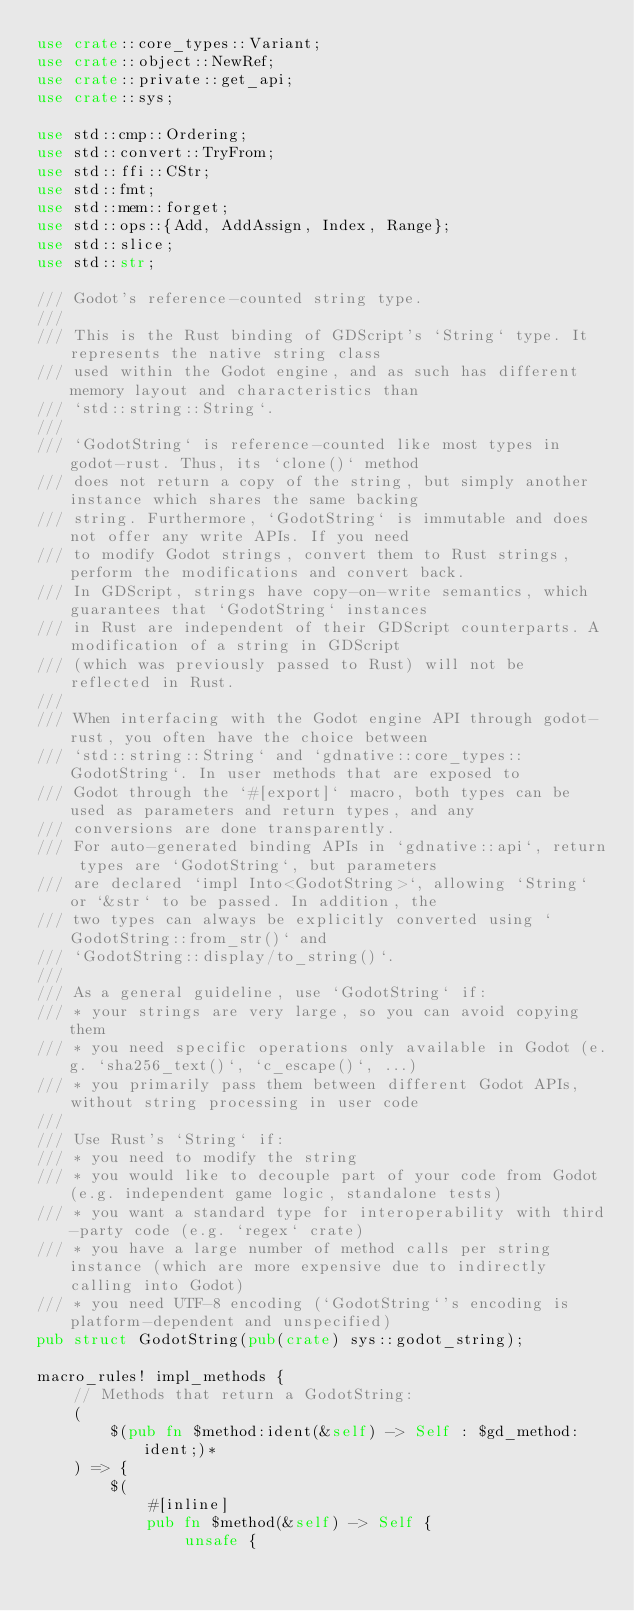<code> <loc_0><loc_0><loc_500><loc_500><_Rust_>use crate::core_types::Variant;
use crate::object::NewRef;
use crate::private::get_api;
use crate::sys;

use std::cmp::Ordering;
use std::convert::TryFrom;
use std::ffi::CStr;
use std::fmt;
use std::mem::forget;
use std::ops::{Add, AddAssign, Index, Range};
use std::slice;
use std::str;

/// Godot's reference-counted string type.
///
/// This is the Rust binding of GDScript's `String` type. It represents the native string class
/// used within the Godot engine, and as such has different memory layout and characteristics than
/// `std::string::String`.
///
/// `GodotString` is reference-counted like most types in godot-rust. Thus, its `clone()` method
/// does not return a copy of the string, but simply another instance which shares the same backing
/// string. Furthermore, `GodotString` is immutable and does not offer any write APIs. If you need
/// to modify Godot strings, convert them to Rust strings, perform the modifications and convert back.
/// In GDScript, strings have copy-on-write semantics, which guarantees that `GodotString` instances
/// in Rust are independent of their GDScript counterparts. A modification of a string in GDScript
/// (which was previously passed to Rust) will not be reflected in Rust.
///
/// When interfacing with the Godot engine API through godot-rust, you often have the choice between
/// `std::string::String` and `gdnative::core_types::GodotString`. In user methods that are exposed to
/// Godot through the `#[export]` macro, both types can be used as parameters and return types, and any
/// conversions are done transparently.
/// For auto-generated binding APIs in `gdnative::api`, return types are `GodotString`, but parameters
/// are declared `impl Into<GodotString>`, allowing `String` or `&str` to be passed. In addition, the
/// two types can always be explicitly converted using `GodotString::from_str()` and
/// `GodotString::display/to_string()`.
///
/// As a general guideline, use `GodotString` if:
/// * your strings are very large, so you can avoid copying them
/// * you need specific operations only available in Godot (e.g. `sha256_text()`, `c_escape()`, ...)
/// * you primarily pass them between different Godot APIs, without string processing in user code
///
/// Use Rust's `String` if:
/// * you need to modify the string
/// * you would like to decouple part of your code from Godot (e.g. independent game logic, standalone tests)
/// * you want a standard type for interoperability with third-party code (e.g. `regex` crate)
/// * you have a large number of method calls per string instance (which are more expensive due to indirectly calling into Godot)
/// * you need UTF-8 encoding (`GodotString`'s encoding is platform-dependent and unspecified)
pub struct GodotString(pub(crate) sys::godot_string);

macro_rules! impl_methods {
    // Methods that return a GodotString:
    (
        $(pub fn $method:ident(&self) -> Self : $gd_method:ident;)*
    ) => {
        $(
            #[inline]
            pub fn $method(&self) -> Self {
                unsafe {</code> 